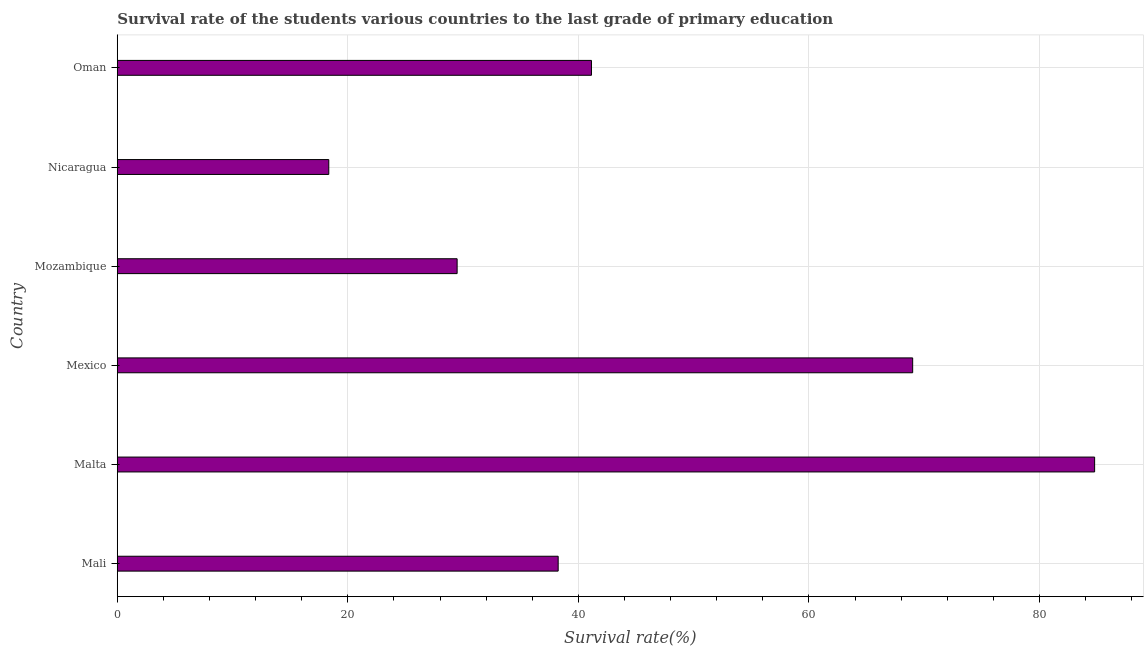Does the graph contain any zero values?
Offer a terse response. No. Does the graph contain grids?
Provide a succinct answer. Yes. What is the title of the graph?
Your answer should be very brief. Survival rate of the students various countries to the last grade of primary education. What is the label or title of the X-axis?
Provide a short and direct response. Survival rate(%). What is the survival rate in primary education in Mozambique?
Offer a terse response. 29.48. Across all countries, what is the maximum survival rate in primary education?
Your response must be concise. 84.79. Across all countries, what is the minimum survival rate in primary education?
Offer a terse response. 18.35. In which country was the survival rate in primary education maximum?
Keep it short and to the point. Malta. In which country was the survival rate in primary education minimum?
Provide a succinct answer. Nicaragua. What is the sum of the survival rate in primary education?
Make the answer very short. 281.01. What is the difference between the survival rate in primary education in Malta and Mexico?
Give a very brief answer. 15.79. What is the average survival rate in primary education per country?
Offer a very short reply. 46.84. What is the median survival rate in primary education?
Provide a succinct answer. 39.69. In how many countries, is the survival rate in primary education greater than 56 %?
Provide a short and direct response. 2. What is the ratio of the survival rate in primary education in Mali to that in Malta?
Provide a succinct answer. 0.45. Is the survival rate in primary education in Mali less than that in Oman?
Your answer should be compact. Yes. Is the difference between the survival rate in primary education in Mexico and Nicaragua greater than the difference between any two countries?
Provide a short and direct response. No. What is the difference between the highest and the second highest survival rate in primary education?
Give a very brief answer. 15.79. What is the difference between the highest and the lowest survival rate in primary education?
Offer a very short reply. 66.44. In how many countries, is the survival rate in primary education greater than the average survival rate in primary education taken over all countries?
Keep it short and to the point. 2. How many countries are there in the graph?
Offer a terse response. 6. Are the values on the major ticks of X-axis written in scientific E-notation?
Your answer should be very brief. No. What is the Survival rate(%) in Mali?
Offer a terse response. 38.25. What is the Survival rate(%) in Malta?
Give a very brief answer. 84.79. What is the Survival rate(%) in Mexico?
Keep it short and to the point. 69. What is the Survival rate(%) of Mozambique?
Give a very brief answer. 29.48. What is the Survival rate(%) of Nicaragua?
Keep it short and to the point. 18.35. What is the Survival rate(%) in Oman?
Your response must be concise. 41.14. What is the difference between the Survival rate(%) in Mali and Malta?
Keep it short and to the point. -46.54. What is the difference between the Survival rate(%) in Mali and Mexico?
Ensure brevity in your answer.  -30.75. What is the difference between the Survival rate(%) in Mali and Mozambique?
Offer a terse response. 8.77. What is the difference between the Survival rate(%) in Mali and Nicaragua?
Provide a short and direct response. 19.9. What is the difference between the Survival rate(%) in Mali and Oman?
Ensure brevity in your answer.  -2.89. What is the difference between the Survival rate(%) in Malta and Mexico?
Make the answer very short. 15.78. What is the difference between the Survival rate(%) in Malta and Mozambique?
Your response must be concise. 55.3. What is the difference between the Survival rate(%) in Malta and Nicaragua?
Keep it short and to the point. 66.44. What is the difference between the Survival rate(%) in Malta and Oman?
Make the answer very short. 43.65. What is the difference between the Survival rate(%) in Mexico and Mozambique?
Provide a succinct answer. 39.52. What is the difference between the Survival rate(%) in Mexico and Nicaragua?
Your answer should be compact. 50.65. What is the difference between the Survival rate(%) in Mexico and Oman?
Your answer should be compact. 27.87. What is the difference between the Survival rate(%) in Mozambique and Nicaragua?
Make the answer very short. 11.13. What is the difference between the Survival rate(%) in Mozambique and Oman?
Your answer should be very brief. -11.65. What is the difference between the Survival rate(%) in Nicaragua and Oman?
Your answer should be compact. -22.79. What is the ratio of the Survival rate(%) in Mali to that in Malta?
Your answer should be compact. 0.45. What is the ratio of the Survival rate(%) in Mali to that in Mexico?
Offer a terse response. 0.55. What is the ratio of the Survival rate(%) in Mali to that in Mozambique?
Give a very brief answer. 1.3. What is the ratio of the Survival rate(%) in Mali to that in Nicaragua?
Provide a short and direct response. 2.08. What is the ratio of the Survival rate(%) in Malta to that in Mexico?
Keep it short and to the point. 1.23. What is the ratio of the Survival rate(%) in Malta to that in Mozambique?
Make the answer very short. 2.88. What is the ratio of the Survival rate(%) in Malta to that in Nicaragua?
Provide a short and direct response. 4.62. What is the ratio of the Survival rate(%) in Malta to that in Oman?
Offer a terse response. 2.06. What is the ratio of the Survival rate(%) in Mexico to that in Mozambique?
Ensure brevity in your answer.  2.34. What is the ratio of the Survival rate(%) in Mexico to that in Nicaragua?
Provide a short and direct response. 3.76. What is the ratio of the Survival rate(%) in Mexico to that in Oman?
Your answer should be compact. 1.68. What is the ratio of the Survival rate(%) in Mozambique to that in Nicaragua?
Your answer should be compact. 1.61. What is the ratio of the Survival rate(%) in Mozambique to that in Oman?
Your response must be concise. 0.72. What is the ratio of the Survival rate(%) in Nicaragua to that in Oman?
Your answer should be very brief. 0.45. 